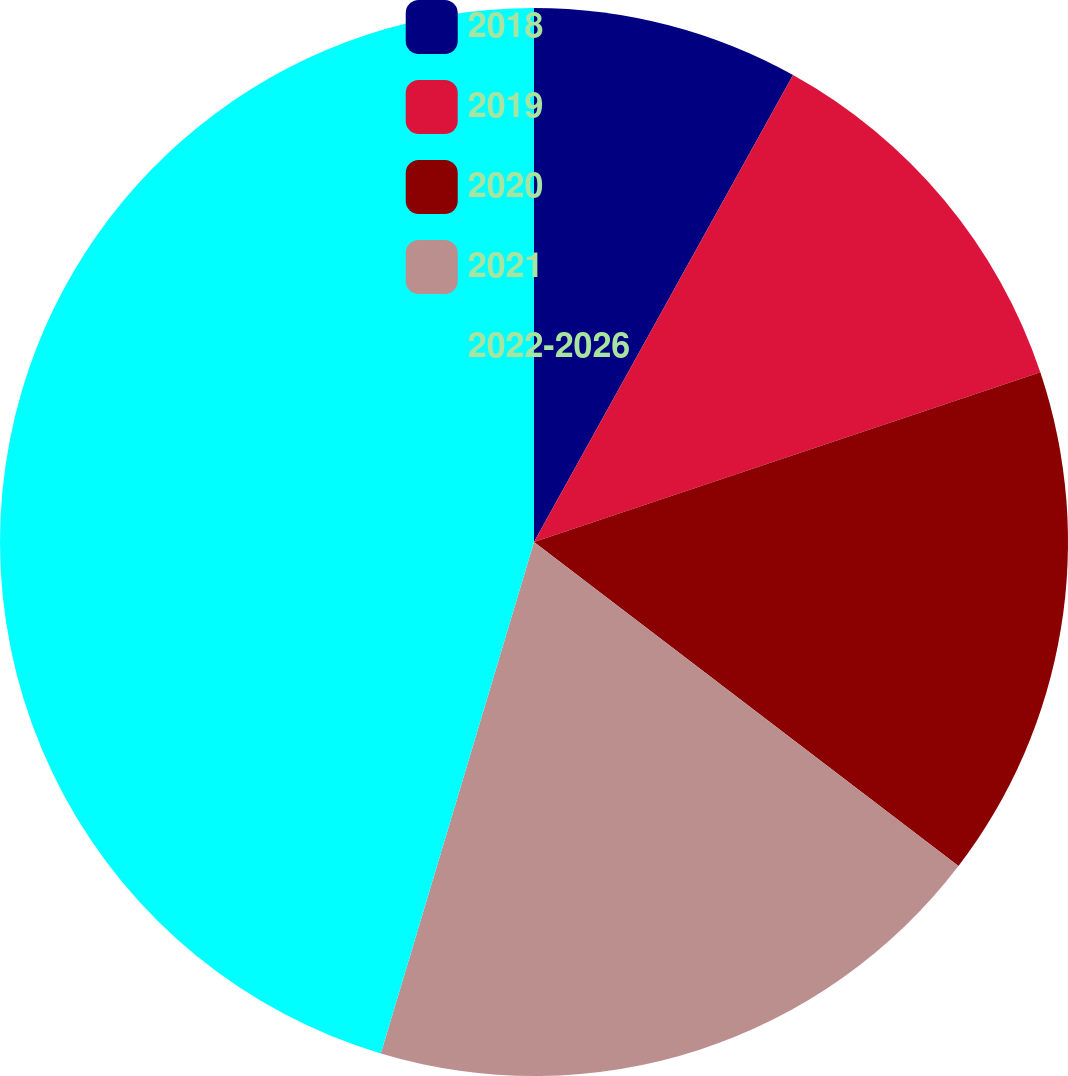Convert chart. <chart><loc_0><loc_0><loc_500><loc_500><pie_chart><fcel>2018<fcel>2019<fcel>2020<fcel>2021<fcel>2022-2026<nl><fcel>8.06%<fcel>11.79%<fcel>15.52%<fcel>19.25%<fcel>45.36%<nl></chart> 